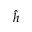<formula> <loc_0><loc_0><loc_500><loc_500>\hat { h }</formula> 